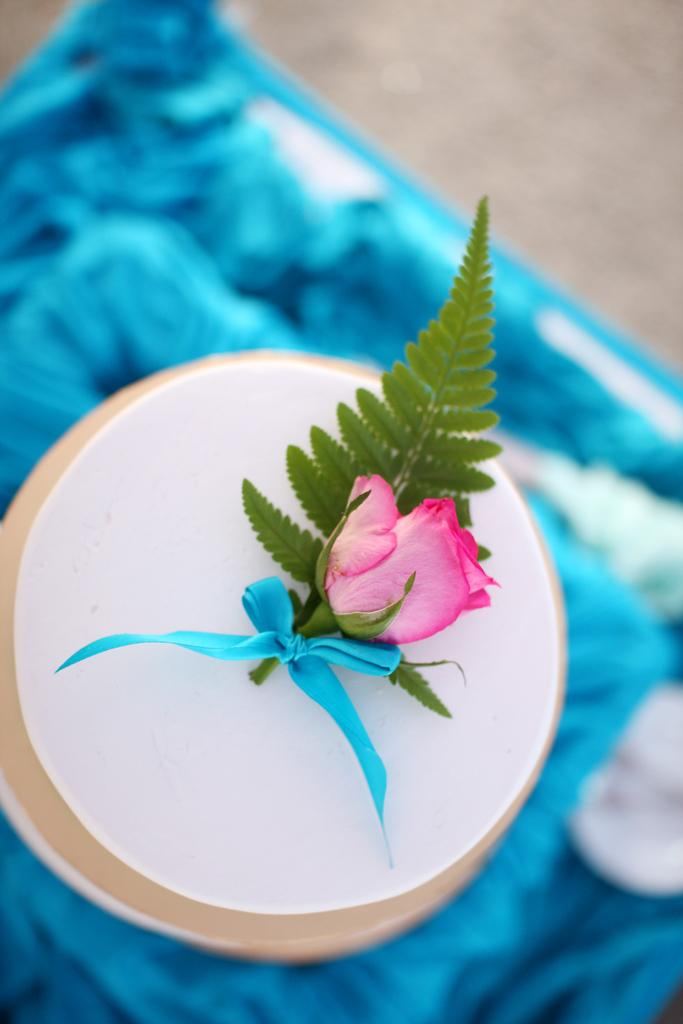What piece of furniture is present in the image? There is a table in the image. What is placed on the table? There is a plate on the table. What type of plant is visible in the image? There is a rose with a leaf in the image. How many mice are running across the table in the image? There are no mice present in the image, and therefore no running mice can be observed. 